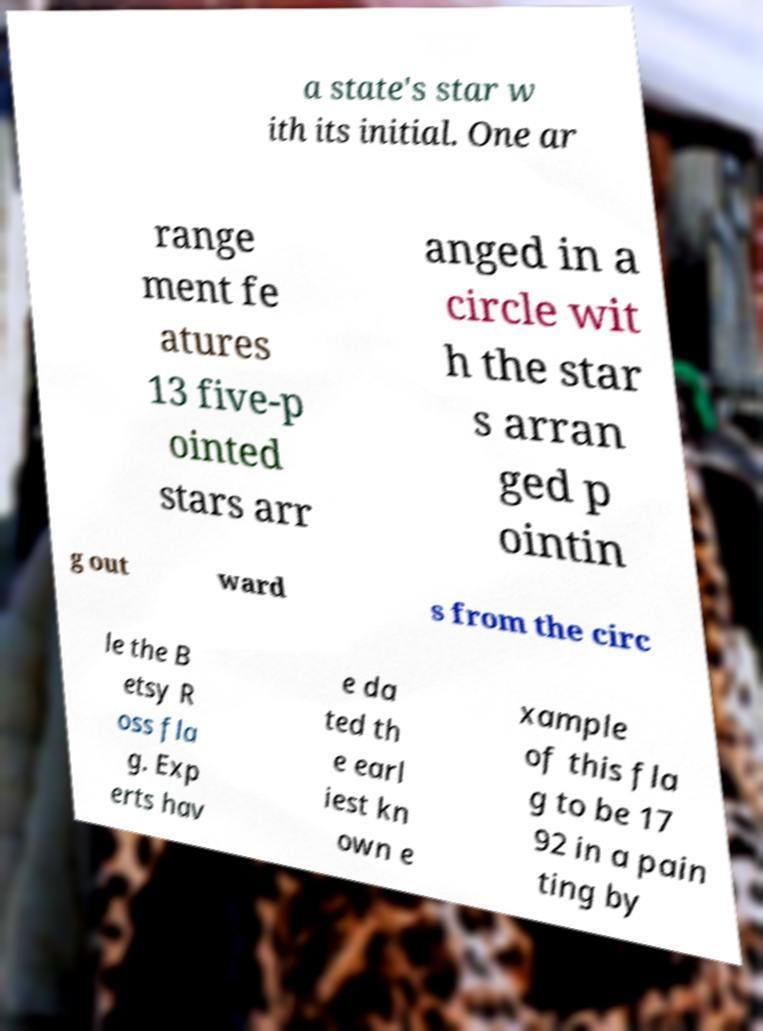Can you accurately transcribe the text from the provided image for me? a state's star w ith its initial. One ar range ment fe atures 13 five-p ointed stars arr anged in a circle wit h the star s arran ged p ointin g out ward s from the circ le the B etsy R oss fla g. Exp erts hav e da ted th e earl iest kn own e xample of this fla g to be 17 92 in a pain ting by 